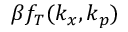Convert formula to latex. <formula><loc_0><loc_0><loc_500><loc_500>\beta f _ { T } ( k _ { x } , k _ { p } )</formula> 